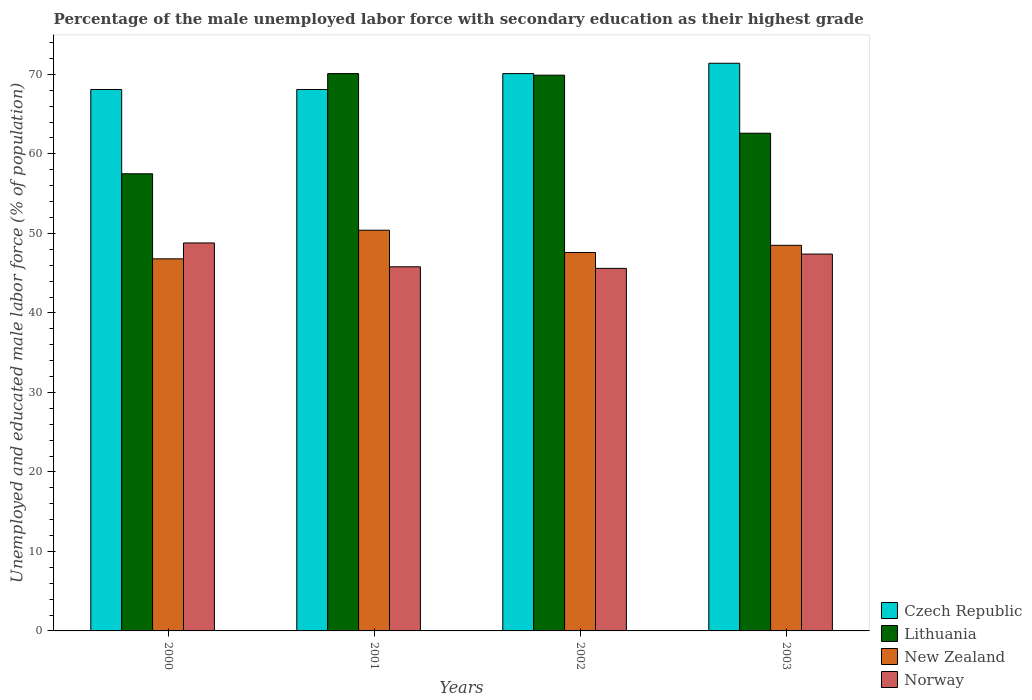How many groups of bars are there?
Give a very brief answer. 4. Are the number of bars per tick equal to the number of legend labels?
Keep it short and to the point. Yes. Are the number of bars on each tick of the X-axis equal?
Provide a succinct answer. Yes. How many bars are there on the 2nd tick from the left?
Your answer should be compact. 4. How many bars are there on the 2nd tick from the right?
Give a very brief answer. 4. In how many cases, is the number of bars for a given year not equal to the number of legend labels?
Your answer should be compact. 0. What is the percentage of the unemployed male labor force with secondary education in Czech Republic in 2001?
Make the answer very short. 68.1. Across all years, what is the maximum percentage of the unemployed male labor force with secondary education in Norway?
Offer a very short reply. 48.8. Across all years, what is the minimum percentage of the unemployed male labor force with secondary education in New Zealand?
Ensure brevity in your answer.  46.8. In which year was the percentage of the unemployed male labor force with secondary education in Czech Republic minimum?
Make the answer very short. 2000. What is the total percentage of the unemployed male labor force with secondary education in Lithuania in the graph?
Your answer should be compact. 260.1. What is the difference between the percentage of the unemployed male labor force with secondary education in Norway in 2000 and that in 2003?
Keep it short and to the point. 1.4. What is the difference between the percentage of the unemployed male labor force with secondary education in Czech Republic in 2001 and the percentage of the unemployed male labor force with secondary education in Lithuania in 2002?
Offer a very short reply. -1.8. What is the average percentage of the unemployed male labor force with secondary education in Lithuania per year?
Your response must be concise. 65.02. In the year 2003, what is the difference between the percentage of the unemployed male labor force with secondary education in Lithuania and percentage of the unemployed male labor force with secondary education in Czech Republic?
Provide a short and direct response. -8.8. In how many years, is the percentage of the unemployed male labor force with secondary education in New Zealand greater than 20 %?
Your answer should be very brief. 4. What is the ratio of the percentage of the unemployed male labor force with secondary education in Lithuania in 2001 to that in 2002?
Offer a very short reply. 1. Is the difference between the percentage of the unemployed male labor force with secondary education in Lithuania in 2001 and 2002 greater than the difference between the percentage of the unemployed male labor force with secondary education in Czech Republic in 2001 and 2002?
Keep it short and to the point. Yes. What is the difference between the highest and the second highest percentage of the unemployed male labor force with secondary education in Czech Republic?
Make the answer very short. 1.3. What is the difference between the highest and the lowest percentage of the unemployed male labor force with secondary education in New Zealand?
Provide a succinct answer. 3.6. In how many years, is the percentage of the unemployed male labor force with secondary education in New Zealand greater than the average percentage of the unemployed male labor force with secondary education in New Zealand taken over all years?
Provide a short and direct response. 2. Is the sum of the percentage of the unemployed male labor force with secondary education in Czech Republic in 2001 and 2003 greater than the maximum percentage of the unemployed male labor force with secondary education in New Zealand across all years?
Provide a short and direct response. Yes. Is it the case that in every year, the sum of the percentage of the unemployed male labor force with secondary education in New Zealand and percentage of the unemployed male labor force with secondary education in Czech Republic is greater than the sum of percentage of the unemployed male labor force with secondary education in Norway and percentage of the unemployed male labor force with secondary education in Lithuania?
Your response must be concise. No. What does the 1st bar from the left in 2002 represents?
Provide a succinct answer. Czech Republic. What does the 1st bar from the right in 2001 represents?
Ensure brevity in your answer.  Norway. Is it the case that in every year, the sum of the percentage of the unemployed male labor force with secondary education in Lithuania and percentage of the unemployed male labor force with secondary education in Norway is greater than the percentage of the unemployed male labor force with secondary education in New Zealand?
Your answer should be very brief. Yes. How many bars are there?
Make the answer very short. 16. How many years are there in the graph?
Provide a short and direct response. 4. What is the difference between two consecutive major ticks on the Y-axis?
Give a very brief answer. 10. Are the values on the major ticks of Y-axis written in scientific E-notation?
Your response must be concise. No. Does the graph contain any zero values?
Give a very brief answer. No. Does the graph contain grids?
Give a very brief answer. No. Where does the legend appear in the graph?
Your answer should be compact. Bottom right. What is the title of the graph?
Ensure brevity in your answer.  Percentage of the male unemployed labor force with secondary education as their highest grade. Does "Eritrea" appear as one of the legend labels in the graph?
Give a very brief answer. No. What is the label or title of the Y-axis?
Give a very brief answer. Unemployed and educated male labor force (% of population). What is the Unemployed and educated male labor force (% of population) of Czech Republic in 2000?
Offer a very short reply. 68.1. What is the Unemployed and educated male labor force (% of population) in Lithuania in 2000?
Ensure brevity in your answer.  57.5. What is the Unemployed and educated male labor force (% of population) of New Zealand in 2000?
Keep it short and to the point. 46.8. What is the Unemployed and educated male labor force (% of population) of Norway in 2000?
Offer a very short reply. 48.8. What is the Unemployed and educated male labor force (% of population) of Czech Republic in 2001?
Ensure brevity in your answer.  68.1. What is the Unemployed and educated male labor force (% of population) of Lithuania in 2001?
Offer a terse response. 70.1. What is the Unemployed and educated male labor force (% of population) in New Zealand in 2001?
Offer a very short reply. 50.4. What is the Unemployed and educated male labor force (% of population) in Norway in 2001?
Provide a succinct answer. 45.8. What is the Unemployed and educated male labor force (% of population) in Czech Republic in 2002?
Offer a terse response. 70.1. What is the Unemployed and educated male labor force (% of population) in Lithuania in 2002?
Provide a short and direct response. 69.9. What is the Unemployed and educated male labor force (% of population) in New Zealand in 2002?
Your response must be concise. 47.6. What is the Unemployed and educated male labor force (% of population) of Norway in 2002?
Provide a short and direct response. 45.6. What is the Unemployed and educated male labor force (% of population) in Czech Republic in 2003?
Your answer should be very brief. 71.4. What is the Unemployed and educated male labor force (% of population) in Lithuania in 2003?
Your response must be concise. 62.6. What is the Unemployed and educated male labor force (% of population) of New Zealand in 2003?
Provide a succinct answer. 48.5. What is the Unemployed and educated male labor force (% of population) of Norway in 2003?
Provide a short and direct response. 47.4. Across all years, what is the maximum Unemployed and educated male labor force (% of population) in Czech Republic?
Ensure brevity in your answer.  71.4. Across all years, what is the maximum Unemployed and educated male labor force (% of population) in Lithuania?
Offer a very short reply. 70.1. Across all years, what is the maximum Unemployed and educated male labor force (% of population) of New Zealand?
Ensure brevity in your answer.  50.4. Across all years, what is the maximum Unemployed and educated male labor force (% of population) of Norway?
Provide a short and direct response. 48.8. Across all years, what is the minimum Unemployed and educated male labor force (% of population) of Czech Republic?
Provide a short and direct response. 68.1. Across all years, what is the minimum Unemployed and educated male labor force (% of population) in Lithuania?
Provide a short and direct response. 57.5. Across all years, what is the minimum Unemployed and educated male labor force (% of population) of New Zealand?
Provide a succinct answer. 46.8. Across all years, what is the minimum Unemployed and educated male labor force (% of population) of Norway?
Make the answer very short. 45.6. What is the total Unemployed and educated male labor force (% of population) in Czech Republic in the graph?
Make the answer very short. 277.7. What is the total Unemployed and educated male labor force (% of population) in Lithuania in the graph?
Ensure brevity in your answer.  260.1. What is the total Unemployed and educated male labor force (% of population) of New Zealand in the graph?
Your answer should be very brief. 193.3. What is the total Unemployed and educated male labor force (% of population) of Norway in the graph?
Ensure brevity in your answer.  187.6. What is the difference between the Unemployed and educated male labor force (% of population) of Lithuania in 2000 and that in 2001?
Your answer should be compact. -12.6. What is the difference between the Unemployed and educated male labor force (% of population) of Norway in 2000 and that in 2001?
Offer a terse response. 3. What is the difference between the Unemployed and educated male labor force (% of population) in Czech Republic in 2000 and that in 2002?
Provide a short and direct response. -2. What is the difference between the Unemployed and educated male labor force (% of population) of Lithuania in 2000 and that in 2002?
Offer a very short reply. -12.4. What is the difference between the Unemployed and educated male labor force (% of population) in Lithuania in 2000 and that in 2003?
Give a very brief answer. -5.1. What is the difference between the Unemployed and educated male labor force (% of population) of New Zealand in 2000 and that in 2003?
Offer a very short reply. -1.7. What is the difference between the Unemployed and educated male labor force (% of population) in Norway in 2000 and that in 2003?
Your response must be concise. 1.4. What is the difference between the Unemployed and educated male labor force (% of population) of Czech Republic in 2001 and that in 2002?
Provide a short and direct response. -2. What is the difference between the Unemployed and educated male labor force (% of population) in Norway in 2001 and that in 2002?
Offer a terse response. 0.2. What is the difference between the Unemployed and educated male labor force (% of population) in Czech Republic in 2001 and that in 2003?
Provide a short and direct response. -3.3. What is the difference between the Unemployed and educated male labor force (% of population) in New Zealand in 2001 and that in 2003?
Provide a short and direct response. 1.9. What is the difference between the Unemployed and educated male labor force (% of population) of Norway in 2001 and that in 2003?
Ensure brevity in your answer.  -1.6. What is the difference between the Unemployed and educated male labor force (% of population) of Lithuania in 2002 and that in 2003?
Provide a short and direct response. 7.3. What is the difference between the Unemployed and educated male labor force (% of population) of Czech Republic in 2000 and the Unemployed and educated male labor force (% of population) of Norway in 2001?
Provide a short and direct response. 22.3. What is the difference between the Unemployed and educated male labor force (% of population) in Lithuania in 2000 and the Unemployed and educated male labor force (% of population) in Norway in 2001?
Keep it short and to the point. 11.7. What is the difference between the Unemployed and educated male labor force (% of population) of New Zealand in 2000 and the Unemployed and educated male labor force (% of population) of Norway in 2001?
Give a very brief answer. 1. What is the difference between the Unemployed and educated male labor force (% of population) of Czech Republic in 2000 and the Unemployed and educated male labor force (% of population) of Lithuania in 2002?
Provide a short and direct response. -1.8. What is the difference between the Unemployed and educated male labor force (% of population) of Czech Republic in 2000 and the Unemployed and educated male labor force (% of population) of New Zealand in 2002?
Give a very brief answer. 20.5. What is the difference between the Unemployed and educated male labor force (% of population) of Czech Republic in 2000 and the Unemployed and educated male labor force (% of population) of Norway in 2002?
Ensure brevity in your answer.  22.5. What is the difference between the Unemployed and educated male labor force (% of population) in Lithuania in 2000 and the Unemployed and educated male labor force (% of population) in New Zealand in 2002?
Offer a very short reply. 9.9. What is the difference between the Unemployed and educated male labor force (% of population) of Lithuania in 2000 and the Unemployed and educated male labor force (% of population) of Norway in 2002?
Your answer should be compact. 11.9. What is the difference between the Unemployed and educated male labor force (% of population) of New Zealand in 2000 and the Unemployed and educated male labor force (% of population) of Norway in 2002?
Offer a terse response. 1.2. What is the difference between the Unemployed and educated male labor force (% of population) of Czech Republic in 2000 and the Unemployed and educated male labor force (% of population) of Lithuania in 2003?
Provide a short and direct response. 5.5. What is the difference between the Unemployed and educated male labor force (% of population) in Czech Republic in 2000 and the Unemployed and educated male labor force (% of population) in New Zealand in 2003?
Offer a very short reply. 19.6. What is the difference between the Unemployed and educated male labor force (% of population) of Czech Republic in 2000 and the Unemployed and educated male labor force (% of population) of Norway in 2003?
Your response must be concise. 20.7. What is the difference between the Unemployed and educated male labor force (% of population) of Lithuania in 2000 and the Unemployed and educated male labor force (% of population) of Norway in 2003?
Your answer should be compact. 10.1. What is the difference between the Unemployed and educated male labor force (% of population) of New Zealand in 2000 and the Unemployed and educated male labor force (% of population) of Norway in 2003?
Offer a terse response. -0.6. What is the difference between the Unemployed and educated male labor force (% of population) in Lithuania in 2001 and the Unemployed and educated male labor force (% of population) in Norway in 2002?
Your answer should be very brief. 24.5. What is the difference between the Unemployed and educated male labor force (% of population) of Czech Republic in 2001 and the Unemployed and educated male labor force (% of population) of New Zealand in 2003?
Keep it short and to the point. 19.6. What is the difference between the Unemployed and educated male labor force (% of population) of Czech Republic in 2001 and the Unemployed and educated male labor force (% of population) of Norway in 2003?
Provide a succinct answer. 20.7. What is the difference between the Unemployed and educated male labor force (% of population) in Lithuania in 2001 and the Unemployed and educated male labor force (% of population) in New Zealand in 2003?
Ensure brevity in your answer.  21.6. What is the difference between the Unemployed and educated male labor force (% of population) in Lithuania in 2001 and the Unemployed and educated male labor force (% of population) in Norway in 2003?
Make the answer very short. 22.7. What is the difference between the Unemployed and educated male labor force (% of population) of Czech Republic in 2002 and the Unemployed and educated male labor force (% of population) of New Zealand in 2003?
Provide a short and direct response. 21.6. What is the difference between the Unemployed and educated male labor force (% of population) in Czech Republic in 2002 and the Unemployed and educated male labor force (% of population) in Norway in 2003?
Provide a succinct answer. 22.7. What is the difference between the Unemployed and educated male labor force (% of population) in Lithuania in 2002 and the Unemployed and educated male labor force (% of population) in New Zealand in 2003?
Make the answer very short. 21.4. What is the average Unemployed and educated male labor force (% of population) of Czech Republic per year?
Provide a succinct answer. 69.42. What is the average Unemployed and educated male labor force (% of population) in Lithuania per year?
Your answer should be very brief. 65.03. What is the average Unemployed and educated male labor force (% of population) of New Zealand per year?
Keep it short and to the point. 48.33. What is the average Unemployed and educated male labor force (% of population) in Norway per year?
Your response must be concise. 46.9. In the year 2000, what is the difference between the Unemployed and educated male labor force (% of population) of Czech Republic and Unemployed and educated male labor force (% of population) of Lithuania?
Give a very brief answer. 10.6. In the year 2000, what is the difference between the Unemployed and educated male labor force (% of population) in Czech Republic and Unemployed and educated male labor force (% of population) in New Zealand?
Ensure brevity in your answer.  21.3. In the year 2000, what is the difference between the Unemployed and educated male labor force (% of population) in Czech Republic and Unemployed and educated male labor force (% of population) in Norway?
Your response must be concise. 19.3. In the year 2000, what is the difference between the Unemployed and educated male labor force (% of population) in Lithuania and Unemployed and educated male labor force (% of population) in New Zealand?
Offer a terse response. 10.7. In the year 2001, what is the difference between the Unemployed and educated male labor force (% of population) of Czech Republic and Unemployed and educated male labor force (% of population) of Lithuania?
Your answer should be compact. -2. In the year 2001, what is the difference between the Unemployed and educated male labor force (% of population) in Czech Republic and Unemployed and educated male labor force (% of population) in Norway?
Your answer should be very brief. 22.3. In the year 2001, what is the difference between the Unemployed and educated male labor force (% of population) of Lithuania and Unemployed and educated male labor force (% of population) of Norway?
Give a very brief answer. 24.3. In the year 2002, what is the difference between the Unemployed and educated male labor force (% of population) in Czech Republic and Unemployed and educated male labor force (% of population) in Lithuania?
Keep it short and to the point. 0.2. In the year 2002, what is the difference between the Unemployed and educated male labor force (% of population) of Czech Republic and Unemployed and educated male labor force (% of population) of New Zealand?
Your response must be concise. 22.5. In the year 2002, what is the difference between the Unemployed and educated male labor force (% of population) of Czech Republic and Unemployed and educated male labor force (% of population) of Norway?
Your answer should be compact. 24.5. In the year 2002, what is the difference between the Unemployed and educated male labor force (% of population) of Lithuania and Unemployed and educated male labor force (% of population) of New Zealand?
Offer a terse response. 22.3. In the year 2002, what is the difference between the Unemployed and educated male labor force (% of population) of Lithuania and Unemployed and educated male labor force (% of population) of Norway?
Keep it short and to the point. 24.3. In the year 2003, what is the difference between the Unemployed and educated male labor force (% of population) in Czech Republic and Unemployed and educated male labor force (% of population) in New Zealand?
Make the answer very short. 22.9. In the year 2003, what is the difference between the Unemployed and educated male labor force (% of population) of Czech Republic and Unemployed and educated male labor force (% of population) of Norway?
Your answer should be very brief. 24. In the year 2003, what is the difference between the Unemployed and educated male labor force (% of population) in Lithuania and Unemployed and educated male labor force (% of population) in New Zealand?
Provide a succinct answer. 14.1. In the year 2003, what is the difference between the Unemployed and educated male labor force (% of population) in Lithuania and Unemployed and educated male labor force (% of population) in Norway?
Your answer should be compact. 15.2. What is the ratio of the Unemployed and educated male labor force (% of population) of Czech Republic in 2000 to that in 2001?
Your answer should be compact. 1. What is the ratio of the Unemployed and educated male labor force (% of population) of Lithuania in 2000 to that in 2001?
Make the answer very short. 0.82. What is the ratio of the Unemployed and educated male labor force (% of population) in New Zealand in 2000 to that in 2001?
Offer a terse response. 0.93. What is the ratio of the Unemployed and educated male labor force (% of population) in Norway in 2000 to that in 2001?
Your response must be concise. 1.07. What is the ratio of the Unemployed and educated male labor force (% of population) of Czech Republic in 2000 to that in 2002?
Your answer should be very brief. 0.97. What is the ratio of the Unemployed and educated male labor force (% of population) of Lithuania in 2000 to that in 2002?
Your response must be concise. 0.82. What is the ratio of the Unemployed and educated male labor force (% of population) in New Zealand in 2000 to that in 2002?
Offer a very short reply. 0.98. What is the ratio of the Unemployed and educated male labor force (% of population) of Norway in 2000 to that in 2002?
Provide a succinct answer. 1.07. What is the ratio of the Unemployed and educated male labor force (% of population) of Czech Republic in 2000 to that in 2003?
Your response must be concise. 0.95. What is the ratio of the Unemployed and educated male labor force (% of population) of Lithuania in 2000 to that in 2003?
Provide a short and direct response. 0.92. What is the ratio of the Unemployed and educated male labor force (% of population) of New Zealand in 2000 to that in 2003?
Give a very brief answer. 0.96. What is the ratio of the Unemployed and educated male labor force (% of population) in Norway in 2000 to that in 2003?
Your answer should be very brief. 1.03. What is the ratio of the Unemployed and educated male labor force (% of population) of Czech Republic in 2001 to that in 2002?
Keep it short and to the point. 0.97. What is the ratio of the Unemployed and educated male labor force (% of population) of Lithuania in 2001 to that in 2002?
Offer a very short reply. 1. What is the ratio of the Unemployed and educated male labor force (% of population) in New Zealand in 2001 to that in 2002?
Offer a very short reply. 1.06. What is the ratio of the Unemployed and educated male labor force (% of population) in Czech Republic in 2001 to that in 2003?
Keep it short and to the point. 0.95. What is the ratio of the Unemployed and educated male labor force (% of population) in Lithuania in 2001 to that in 2003?
Give a very brief answer. 1.12. What is the ratio of the Unemployed and educated male labor force (% of population) of New Zealand in 2001 to that in 2003?
Your response must be concise. 1.04. What is the ratio of the Unemployed and educated male labor force (% of population) in Norway in 2001 to that in 2003?
Your response must be concise. 0.97. What is the ratio of the Unemployed and educated male labor force (% of population) of Czech Republic in 2002 to that in 2003?
Provide a succinct answer. 0.98. What is the ratio of the Unemployed and educated male labor force (% of population) in Lithuania in 2002 to that in 2003?
Give a very brief answer. 1.12. What is the ratio of the Unemployed and educated male labor force (% of population) of New Zealand in 2002 to that in 2003?
Provide a short and direct response. 0.98. What is the ratio of the Unemployed and educated male labor force (% of population) in Norway in 2002 to that in 2003?
Keep it short and to the point. 0.96. What is the difference between the highest and the second highest Unemployed and educated male labor force (% of population) in Czech Republic?
Offer a terse response. 1.3. What is the difference between the highest and the second highest Unemployed and educated male labor force (% of population) in Lithuania?
Your response must be concise. 0.2. What is the difference between the highest and the second highest Unemployed and educated male labor force (% of population) in Norway?
Your response must be concise. 1.4. 